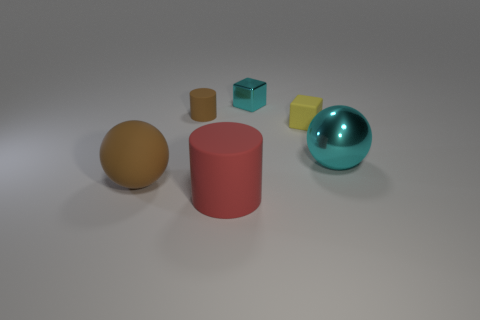There is a big matte thing in front of the big brown rubber ball; what shape is it?
Provide a short and direct response. Cylinder. Is there any other thing that is the same shape as the yellow matte thing?
Your answer should be very brief. Yes. Are there any yellow matte cubes?
Ensure brevity in your answer.  Yes. There is a object to the left of the brown cylinder; does it have the same size as the sphere that is right of the cyan shiny cube?
Your answer should be very brief. Yes. What is the big object that is both on the right side of the brown rubber cylinder and left of the yellow matte object made of?
Make the answer very short. Rubber. There is a brown cylinder; how many balls are left of it?
Offer a very short reply. 1. Is there any other thing that is the same size as the brown cylinder?
Provide a short and direct response. Yes. The other big thing that is made of the same material as the red object is what color?
Offer a terse response. Brown. Is the big cyan thing the same shape as the yellow rubber object?
Provide a short and direct response. No. How many rubber things are right of the tiny cyan object and in front of the yellow matte block?
Ensure brevity in your answer.  0. 